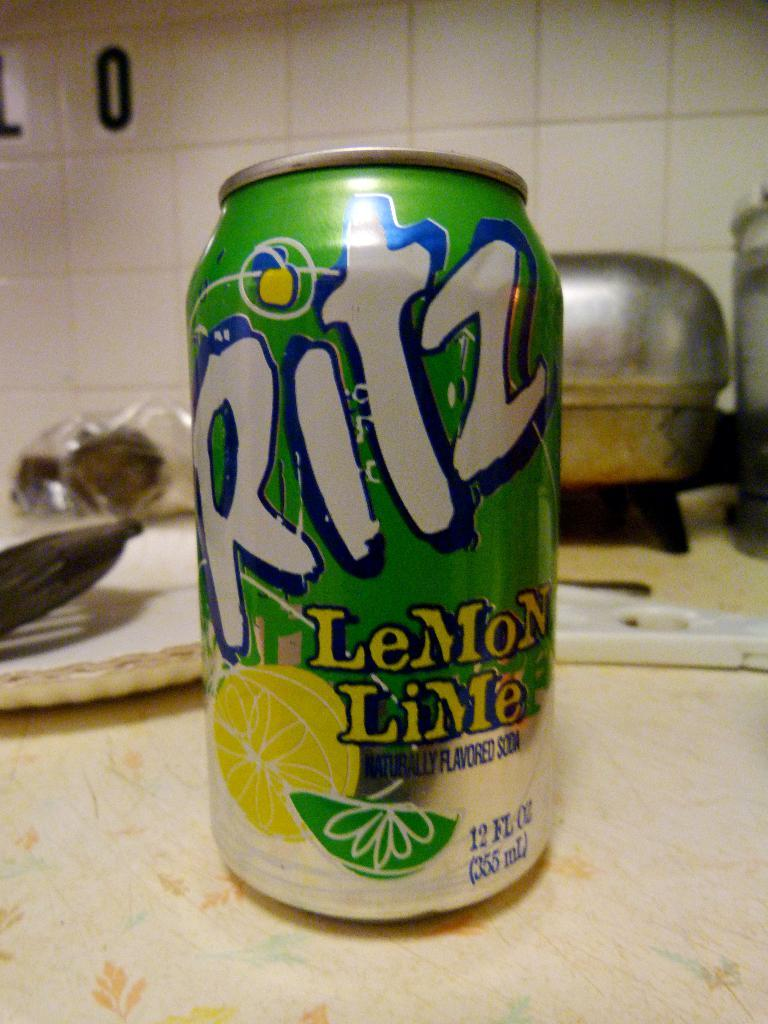<image>
Write a terse but informative summary of the picture. a Ritz can that on top of a white surface 